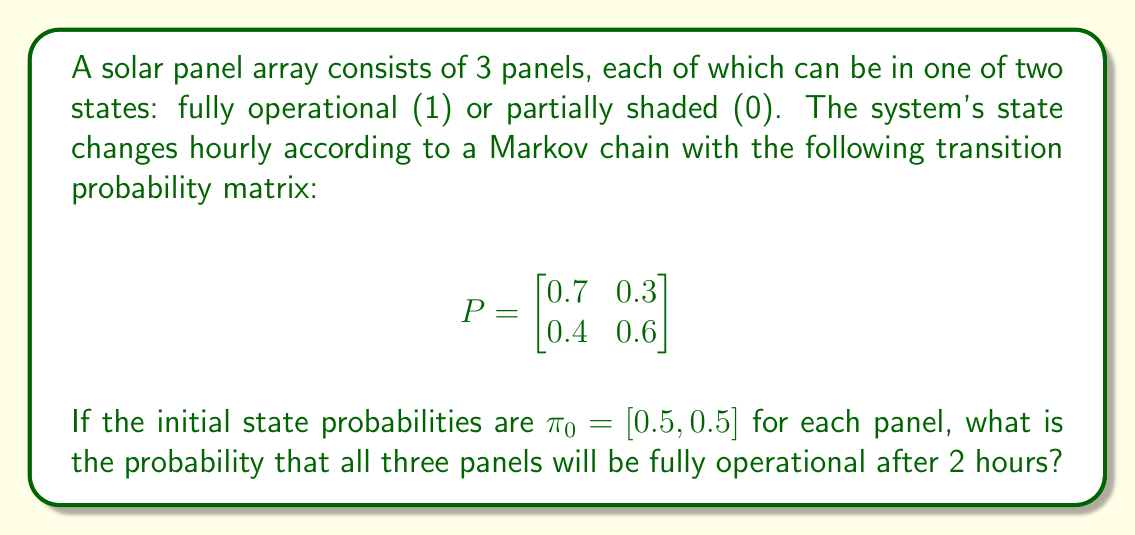Provide a solution to this math problem. To solve this problem, we need to follow these steps:

1) First, we need to calculate the state probabilities after 2 hours. We can do this by multiplying the initial state vector by the transition matrix twice:

   $$\pi_2 = \pi_0 P^2$$

2) Let's calculate $P^2$:

   $$P^2 = \begin{bmatrix}
   0.7 & 0.3 \\
   0.4 & 0.6
   \end{bmatrix} \times \begin{bmatrix}
   0.7 & 0.3 \\
   0.4 & 0.6
   \end{bmatrix} = \begin{bmatrix}
   0.61 & 0.39 \\
   0.52 & 0.48
   \end{bmatrix}$$

3) Now we can calculate $\pi_2$:

   $$\pi_2 = [0.5, 0.5] \times \begin{bmatrix}
   0.61 & 0.39 \\
   0.52 & 0.48
   \end{bmatrix} = [0.565, 0.435]$$

4) The probability of a single panel being fully operational after 2 hours is 0.565.

5) Since we need all three panels to be fully operational, and the panels are independent, we multiply this probability by itself three times:

   $$0.565^3 = 0.180$$

Therefore, the probability that all three panels will be fully operational after 2 hours is approximately 0.180 or 18.0%.
Answer: 0.180 